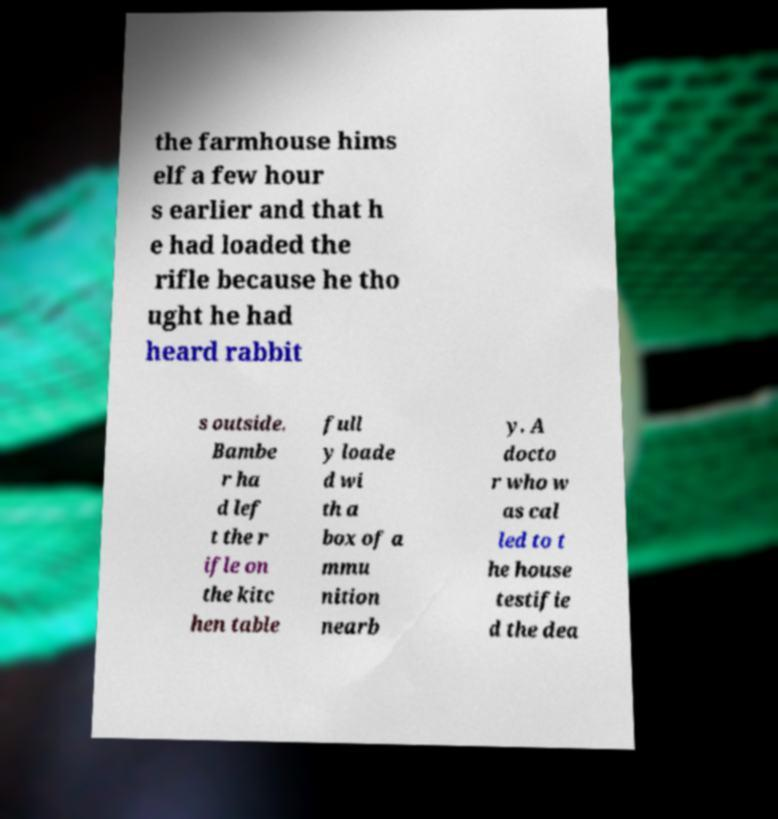What messages or text are displayed in this image? I need them in a readable, typed format. the farmhouse hims elf a few hour s earlier and that h e had loaded the rifle because he tho ught he had heard rabbit s outside. Bambe r ha d lef t the r ifle on the kitc hen table full y loade d wi th a box of a mmu nition nearb y. A docto r who w as cal led to t he house testifie d the dea 